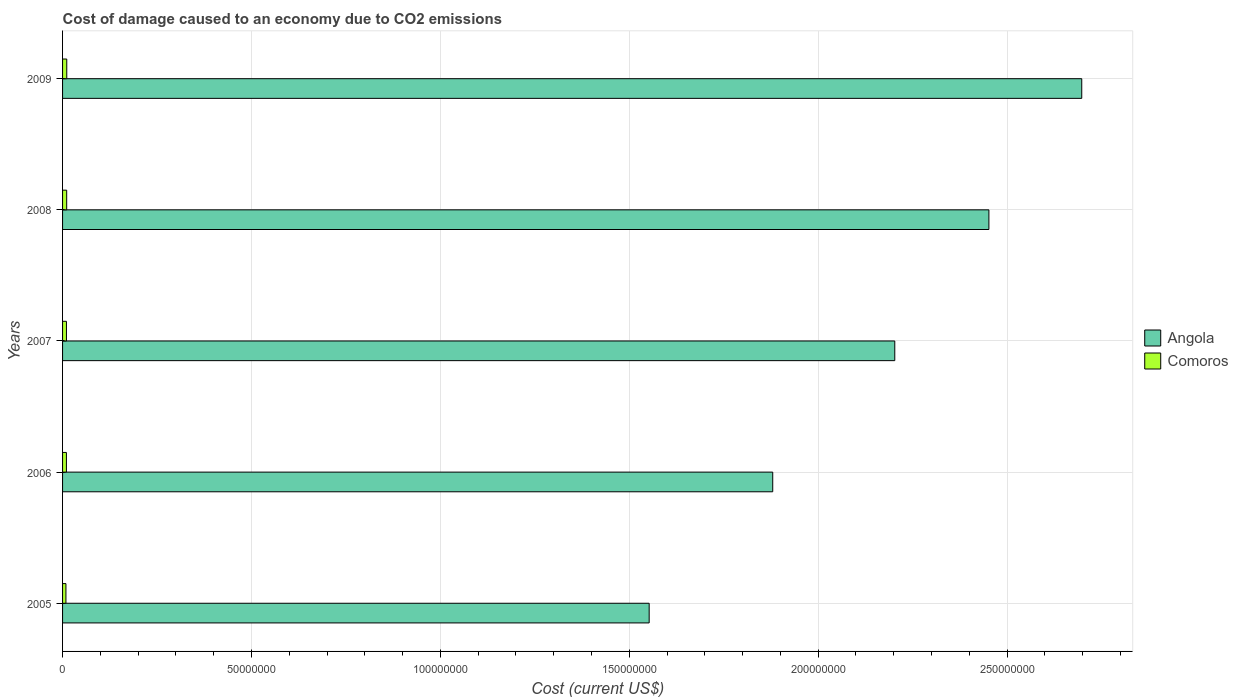How many groups of bars are there?
Offer a very short reply. 5. Are the number of bars on each tick of the Y-axis equal?
Keep it short and to the point. Yes. How many bars are there on the 4th tick from the bottom?
Provide a succinct answer. 2. What is the label of the 2nd group of bars from the top?
Make the answer very short. 2008. In how many cases, is the number of bars for a given year not equal to the number of legend labels?
Give a very brief answer. 0. What is the cost of damage caused due to CO2 emissisons in Comoros in 2005?
Provide a succinct answer. 8.92e+05. Across all years, what is the maximum cost of damage caused due to CO2 emissisons in Comoros?
Offer a very short reply. 1.11e+06. Across all years, what is the minimum cost of damage caused due to CO2 emissisons in Angola?
Provide a short and direct response. 1.55e+08. What is the total cost of damage caused due to CO2 emissisons in Angola in the graph?
Keep it short and to the point. 1.08e+09. What is the difference between the cost of damage caused due to CO2 emissisons in Angola in 2005 and that in 2009?
Offer a terse response. -1.15e+08. What is the difference between the cost of damage caused due to CO2 emissisons in Angola in 2006 and the cost of damage caused due to CO2 emissisons in Comoros in 2008?
Your answer should be very brief. 1.87e+08. What is the average cost of damage caused due to CO2 emissisons in Angola per year?
Your answer should be very brief. 2.16e+08. In the year 2008, what is the difference between the cost of damage caused due to CO2 emissisons in Angola and cost of damage caused due to CO2 emissisons in Comoros?
Offer a very short reply. 2.44e+08. What is the ratio of the cost of damage caused due to CO2 emissisons in Comoros in 2006 to that in 2007?
Provide a succinct answer. 0.99. What is the difference between the highest and the second highest cost of damage caused due to CO2 emissisons in Angola?
Ensure brevity in your answer.  2.46e+07. What is the difference between the highest and the lowest cost of damage caused due to CO2 emissisons in Comoros?
Provide a short and direct response. 2.20e+05. In how many years, is the cost of damage caused due to CO2 emissisons in Comoros greater than the average cost of damage caused due to CO2 emissisons in Comoros taken over all years?
Ensure brevity in your answer.  2. Is the sum of the cost of damage caused due to CO2 emissisons in Comoros in 2006 and 2009 greater than the maximum cost of damage caused due to CO2 emissisons in Angola across all years?
Give a very brief answer. No. What does the 1st bar from the top in 2006 represents?
Keep it short and to the point. Comoros. What does the 2nd bar from the bottom in 2009 represents?
Give a very brief answer. Comoros. How many bars are there?
Your answer should be very brief. 10. How many years are there in the graph?
Offer a very short reply. 5. What is the difference between two consecutive major ticks on the X-axis?
Give a very brief answer. 5.00e+07. Are the values on the major ticks of X-axis written in scientific E-notation?
Offer a terse response. No. Does the graph contain any zero values?
Give a very brief answer. No. Does the graph contain grids?
Offer a very short reply. Yes. Where does the legend appear in the graph?
Ensure brevity in your answer.  Center right. What is the title of the graph?
Give a very brief answer. Cost of damage caused to an economy due to CO2 emissions. What is the label or title of the X-axis?
Provide a succinct answer. Cost (current US$). What is the label or title of the Y-axis?
Keep it short and to the point. Years. What is the Cost (current US$) of Angola in 2005?
Provide a short and direct response. 1.55e+08. What is the Cost (current US$) of Comoros in 2005?
Make the answer very short. 8.92e+05. What is the Cost (current US$) in Angola in 2006?
Your response must be concise. 1.88e+08. What is the Cost (current US$) of Comoros in 2006?
Make the answer very short. 1.02e+06. What is the Cost (current US$) in Angola in 2007?
Ensure brevity in your answer.  2.20e+08. What is the Cost (current US$) of Comoros in 2007?
Keep it short and to the point. 1.03e+06. What is the Cost (current US$) in Angola in 2008?
Your answer should be compact. 2.45e+08. What is the Cost (current US$) in Comoros in 2008?
Make the answer very short. 1.09e+06. What is the Cost (current US$) of Angola in 2009?
Make the answer very short. 2.70e+08. What is the Cost (current US$) in Comoros in 2009?
Ensure brevity in your answer.  1.11e+06. Across all years, what is the maximum Cost (current US$) in Angola?
Offer a terse response. 2.70e+08. Across all years, what is the maximum Cost (current US$) of Comoros?
Give a very brief answer. 1.11e+06. Across all years, what is the minimum Cost (current US$) in Angola?
Provide a short and direct response. 1.55e+08. Across all years, what is the minimum Cost (current US$) in Comoros?
Give a very brief answer. 8.92e+05. What is the total Cost (current US$) of Angola in the graph?
Keep it short and to the point. 1.08e+09. What is the total Cost (current US$) of Comoros in the graph?
Offer a terse response. 5.14e+06. What is the difference between the Cost (current US$) in Angola in 2005 and that in 2006?
Your answer should be very brief. -3.27e+07. What is the difference between the Cost (current US$) of Comoros in 2005 and that in 2006?
Your response must be concise. -1.30e+05. What is the difference between the Cost (current US$) in Angola in 2005 and that in 2007?
Make the answer very short. -6.50e+07. What is the difference between the Cost (current US$) in Comoros in 2005 and that in 2007?
Ensure brevity in your answer.  -1.36e+05. What is the difference between the Cost (current US$) in Angola in 2005 and that in 2008?
Your answer should be very brief. -8.99e+07. What is the difference between the Cost (current US$) of Comoros in 2005 and that in 2008?
Your answer should be very brief. -2.00e+05. What is the difference between the Cost (current US$) in Angola in 2005 and that in 2009?
Your answer should be very brief. -1.15e+08. What is the difference between the Cost (current US$) of Comoros in 2005 and that in 2009?
Your answer should be very brief. -2.20e+05. What is the difference between the Cost (current US$) of Angola in 2006 and that in 2007?
Make the answer very short. -3.23e+07. What is the difference between the Cost (current US$) of Comoros in 2006 and that in 2007?
Offer a terse response. -6095.02. What is the difference between the Cost (current US$) of Angola in 2006 and that in 2008?
Provide a short and direct response. -5.72e+07. What is the difference between the Cost (current US$) in Comoros in 2006 and that in 2008?
Your answer should be compact. -7.04e+04. What is the difference between the Cost (current US$) in Angola in 2006 and that in 2009?
Offer a very short reply. -8.18e+07. What is the difference between the Cost (current US$) of Comoros in 2006 and that in 2009?
Offer a terse response. -9.02e+04. What is the difference between the Cost (current US$) in Angola in 2007 and that in 2008?
Your answer should be compact. -2.49e+07. What is the difference between the Cost (current US$) in Comoros in 2007 and that in 2008?
Offer a very short reply. -6.43e+04. What is the difference between the Cost (current US$) of Angola in 2007 and that in 2009?
Your answer should be very brief. -4.95e+07. What is the difference between the Cost (current US$) of Comoros in 2007 and that in 2009?
Offer a very short reply. -8.41e+04. What is the difference between the Cost (current US$) of Angola in 2008 and that in 2009?
Give a very brief answer. -2.46e+07. What is the difference between the Cost (current US$) in Comoros in 2008 and that in 2009?
Ensure brevity in your answer.  -1.99e+04. What is the difference between the Cost (current US$) in Angola in 2005 and the Cost (current US$) in Comoros in 2006?
Keep it short and to the point. 1.54e+08. What is the difference between the Cost (current US$) of Angola in 2005 and the Cost (current US$) of Comoros in 2007?
Offer a very short reply. 1.54e+08. What is the difference between the Cost (current US$) of Angola in 2005 and the Cost (current US$) of Comoros in 2008?
Keep it short and to the point. 1.54e+08. What is the difference between the Cost (current US$) in Angola in 2005 and the Cost (current US$) in Comoros in 2009?
Provide a succinct answer. 1.54e+08. What is the difference between the Cost (current US$) of Angola in 2006 and the Cost (current US$) of Comoros in 2007?
Make the answer very short. 1.87e+08. What is the difference between the Cost (current US$) in Angola in 2006 and the Cost (current US$) in Comoros in 2008?
Provide a succinct answer. 1.87e+08. What is the difference between the Cost (current US$) of Angola in 2006 and the Cost (current US$) of Comoros in 2009?
Your answer should be very brief. 1.87e+08. What is the difference between the Cost (current US$) of Angola in 2007 and the Cost (current US$) of Comoros in 2008?
Offer a very short reply. 2.19e+08. What is the difference between the Cost (current US$) in Angola in 2007 and the Cost (current US$) in Comoros in 2009?
Ensure brevity in your answer.  2.19e+08. What is the difference between the Cost (current US$) in Angola in 2008 and the Cost (current US$) in Comoros in 2009?
Give a very brief answer. 2.44e+08. What is the average Cost (current US$) in Angola per year?
Give a very brief answer. 2.16e+08. What is the average Cost (current US$) of Comoros per year?
Your answer should be compact. 1.03e+06. In the year 2005, what is the difference between the Cost (current US$) of Angola and Cost (current US$) of Comoros?
Ensure brevity in your answer.  1.54e+08. In the year 2006, what is the difference between the Cost (current US$) in Angola and Cost (current US$) in Comoros?
Provide a short and direct response. 1.87e+08. In the year 2007, what is the difference between the Cost (current US$) of Angola and Cost (current US$) of Comoros?
Your response must be concise. 2.19e+08. In the year 2008, what is the difference between the Cost (current US$) in Angola and Cost (current US$) in Comoros?
Offer a terse response. 2.44e+08. In the year 2009, what is the difference between the Cost (current US$) in Angola and Cost (current US$) in Comoros?
Provide a succinct answer. 2.69e+08. What is the ratio of the Cost (current US$) of Angola in 2005 to that in 2006?
Your response must be concise. 0.83. What is the ratio of the Cost (current US$) of Comoros in 2005 to that in 2006?
Give a very brief answer. 0.87. What is the ratio of the Cost (current US$) of Angola in 2005 to that in 2007?
Your response must be concise. 0.7. What is the ratio of the Cost (current US$) in Comoros in 2005 to that in 2007?
Provide a short and direct response. 0.87. What is the ratio of the Cost (current US$) in Angola in 2005 to that in 2008?
Your answer should be compact. 0.63. What is the ratio of the Cost (current US$) in Comoros in 2005 to that in 2008?
Ensure brevity in your answer.  0.82. What is the ratio of the Cost (current US$) in Angola in 2005 to that in 2009?
Provide a succinct answer. 0.58. What is the ratio of the Cost (current US$) of Comoros in 2005 to that in 2009?
Give a very brief answer. 0.8. What is the ratio of the Cost (current US$) in Angola in 2006 to that in 2007?
Your response must be concise. 0.85. What is the ratio of the Cost (current US$) in Comoros in 2006 to that in 2007?
Your response must be concise. 0.99. What is the ratio of the Cost (current US$) of Angola in 2006 to that in 2008?
Offer a very short reply. 0.77. What is the ratio of the Cost (current US$) of Comoros in 2006 to that in 2008?
Offer a very short reply. 0.94. What is the ratio of the Cost (current US$) in Angola in 2006 to that in 2009?
Provide a short and direct response. 0.7. What is the ratio of the Cost (current US$) of Comoros in 2006 to that in 2009?
Keep it short and to the point. 0.92. What is the ratio of the Cost (current US$) in Angola in 2007 to that in 2008?
Ensure brevity in your answer.  0.9. What is the ratio of the Cost (current US$) of Comoros in 2007 to that in 2008?
Your answer should be compact. 0.94. What is the ratio of the Cost (current US$) of Angola in 2007 to that in 2009?
Your answer should be compact. 0.82. What is the ratio of the Cost (current US$) in Comoros in 2007 to that in 2009?
Offer a very short reply. 0.92. What is the ratio of the Cost (current US$) of Angola in 2008 to that in 2009?
Give a very brief answer. 0.91. What is the ratio of the Cost (current US$) of Comoros in 2008 to that in 2009?
Your response must be concise. 0.98. What is the difference between the highest and the second highest Cost (current US$) of Angola?
Your answer should be compact. 2.46e+07. What is the difference between the highest and the second highest Cost (current US$) of Comoros?
Make the answer very short. 1.99e+04. What is the difference between the highest and the lowest Cost (current US$) of Angola?
Make the answer very short. 1.15e+08. What is the difference between the highest and the lowest Cost (current US$) of Comoros?
Your answer should be very brief. 2.20e+05. 